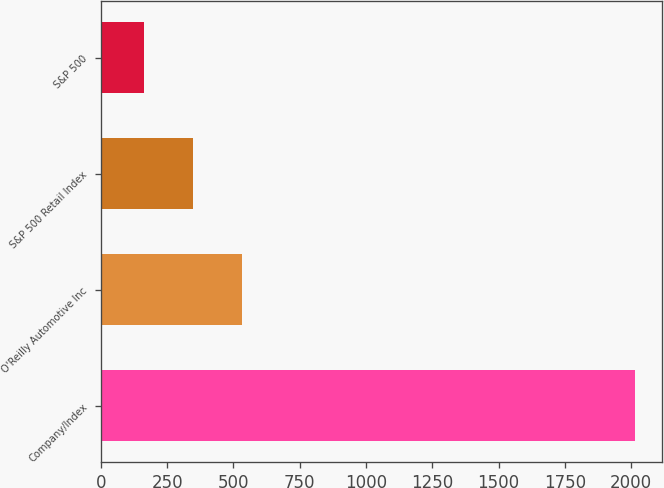<chart> <loc_0><loc_0><loc_500><loc_500><bar_chart><fcel>Company/Index<fcel>O'Reilly Automotive Inc<fcel>S&P 500 Retail Index<fcel>S&P 500<nl><fcel>2015<fcel>533.4<fcel>348.2<fcel>163<nl></chart> 